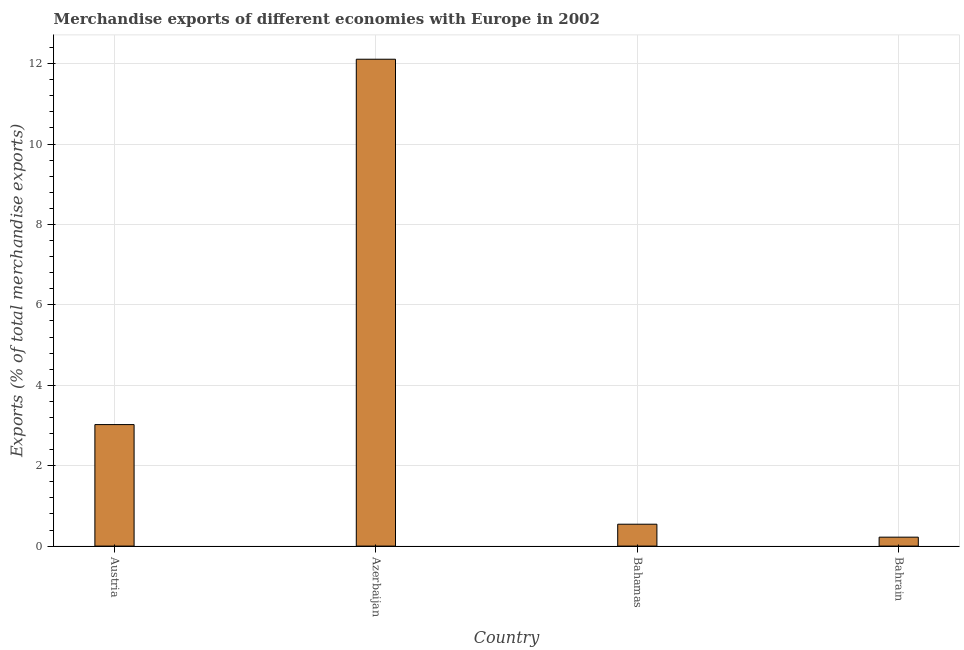Does the graph contain any zero values?
Provide a short and direct response. No. What is the title of the graph?
Offer a very short reply. Merchandise exports of different economies with Europe in 2002. What is the label or title of the Y-axis?
Offer a very short reply. Exports (% of total merchandise exports). What is the merchandise exports in Azerbaijan?
Make the answer very short. 12.11. Across all countries, what is the maximum merchandise exports?
Keep it short and to the point. 12.11. Across all countries, what is the minimum merchandise exports?
Offer a terse response. 0.22. In which country was the merchandise exports maximum?
Keep it short and to the point. Azerbaijan. In which country was the merchandise exports minimum?
Your response must be concise. Bahrain. What is the sum of the merchandise exports?
Make the answer very short. 15.9. What is the difference between the merchandise exports in Azerbaijan and Bahamas?
Make the answer very short. 11.56. What is the average merchandise exports per country?
Make the answer very short. 3.97. What is the median merchandise exports?
Provide a short and direct response. 1.78. What is the ratio of the merchandise exports in Austria to that in Bahamas?
Provide a succinct answer. 5.55. Is the difference between the merchandise exports in Azerbaijan and Bahamas greater than the difference between any two countries?
Your response must be concise. No. What is the difference between the highest and the second highest merchandise exports?
Ensure brevity in your answer.  9.09. What is the difference between the highest and the lowest merchandise exports?
Provide a succinct answer. 11.89. What is the difference between two consecutive major ticks on the Y-axis?
Make the answer very short. 2. What is the Exports (% of total merchandise exports) in Austria?
Provide a succinct answer. 3.02. What is the Exports (% of total merchandise exports) in Azerbaijan?
Make the answer very short. 12.11. What is the Exports (% of total merchandise exports) in Bahamas?
Provide a succinct answer. 0.54. What is the Exports (% of total merchandise exports) in Bahrain?
Offer a terse response. 0.22. What is the difference between the Exports (% of total merchandise exports) in Austria and Azerbaijan?
Give a very brief answer. -9.09. What is the difference between the Exports (% of total merchandise exports) in Austria and Bahamas?
Ensure brevity in your answer.  2.48. What is the difference between the Exports (% of total merchandise exports) in Austria and Bahrain?
Ensure brevity in your answer.  2.8. What is the difference between the Exports (% of total merchandise exports) in Azerbaijan and Bahamas?
Your answer should be compact. 11.57. What is the difference between the Exports (% of total merchandise exports) in Azerbaijan and Bahrain?
Offer a terse response. 11.89. What is the difference between the Exports (% of total merchandise exports) in Bahamas and Bahrain?
Provide a short and direct response. 0.32. What is the ratio of the Exports (% of total merchandise exports) in Austria to that in Azerbaijan?
Keep it short and to the point. 0.25. What is the ratio of the Exports (% of total merchandise exports) in Austria to that in Bahamas?
Keep it short and to the point. 5.55. What is the ratio of the Exports (% of total merchandise exports) in Austria to that in Bahrain?
Provide a short and direct response. 13.61. What is the ratio of the Exports (% of total merchandise exports) in Azerbaijan to that in Bahamas?
Offer a very short reply. 22.25. What is the ratio of the Exports (% of total merchandise exports) in Azerbaijan to that in Bahrain?
Keep it short and to the point. 54.52. What is the ratio of the Exports (% of total merchandise exports) in Bahamas to that in Bahrain?
Provide a short and direct response. 2.45. 